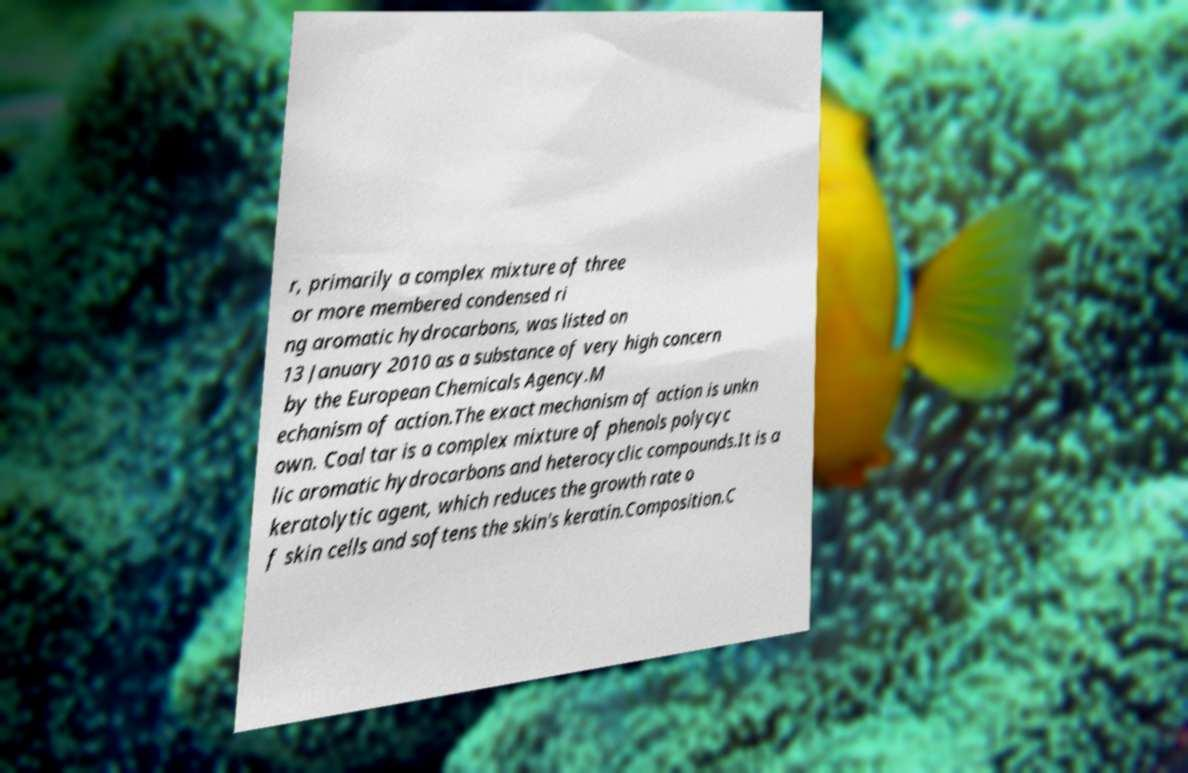Could you extract and type out the text from this image? r, primarily a complex mixture of three or more membered condensed ri ng aromatic hydrocarbons, was listed on 13 January 2010 as a substance of very high concern by the European Chemicals Agency.M echanism of action.The exact mechanism of action is unkn own. Coal tar is a complex mixture of phenols polycyc lic aromatic hydrocarbons and heterocyclic compounds.It is a keratolytic agent, which reduces the growth rate o f skin cells and softens the skin's keratin.Composition.C 